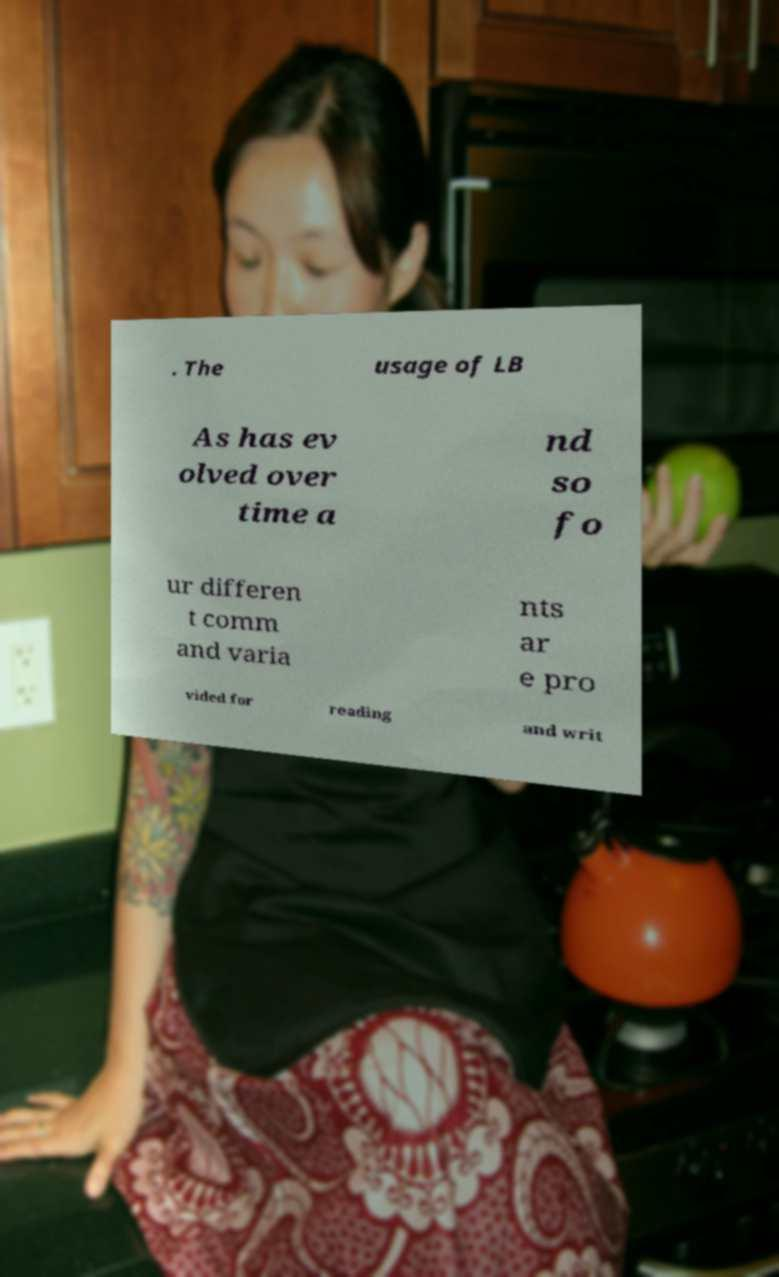Could you assist in decoding the text presented in this image and type it out clearly? . The usage of LB As has ev olved over time a nd so fo ur differen t comm and varia nts ar e pro vided for reading and writ 